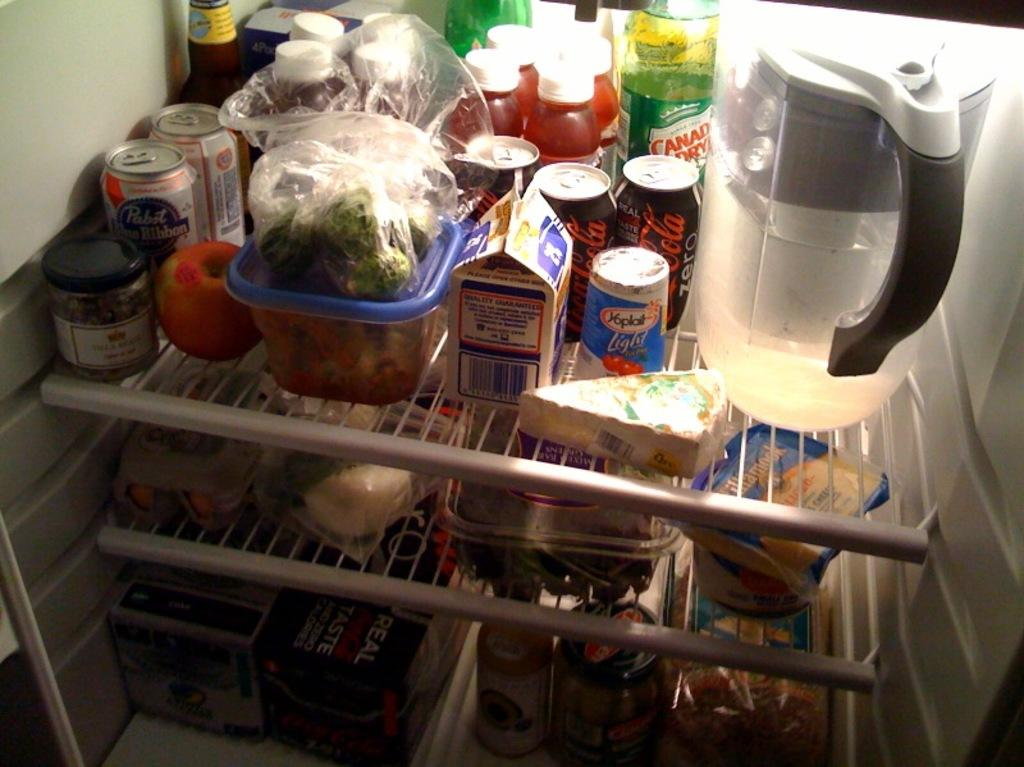What is the main object in the image? There is a fridge in the image. What can be found on the racks of the fridge? On the racks of the fridge, there are soda cans, bottles, fruits, food items, jars, jugs, and boxes. Are there any other objects on the racks of the fridge? Yes, there are other objects on the racks of the fridge. What type of comfort can be seen in the image? There is no reference to comfort in the image; it features a fridge with various items on its racks. Is there a sign indicating the weight of the fridge in the image? There is no sign or indication of the weight of the fridge in the image. 